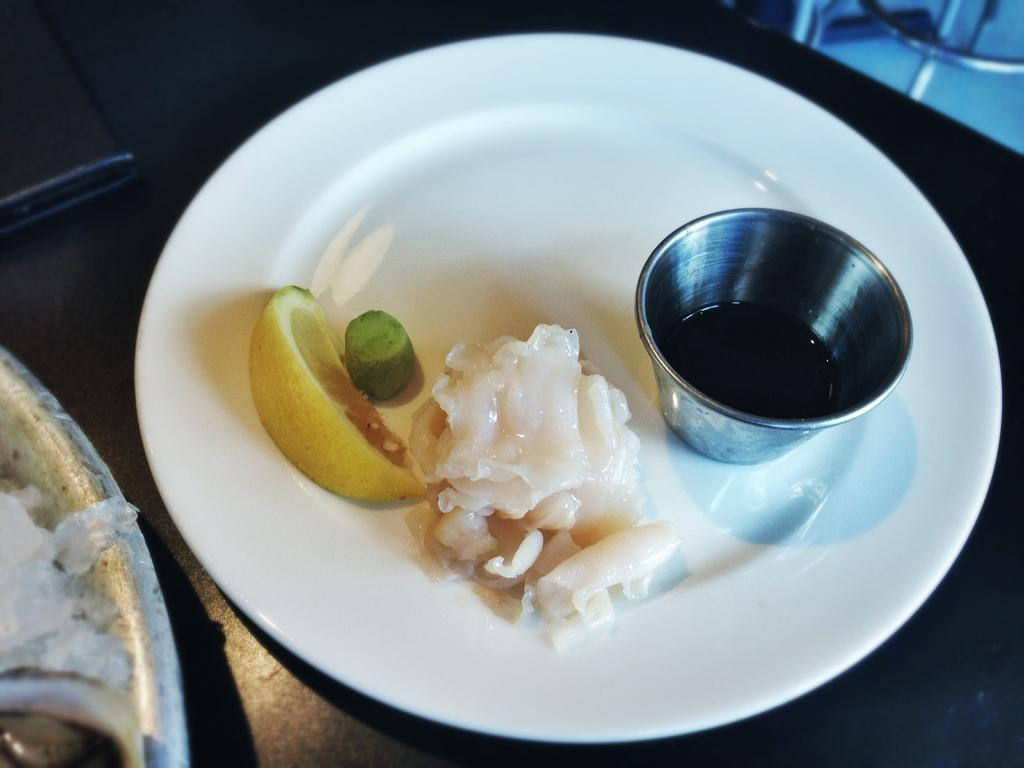What is in the bowl that is visible in the image? There is a bowl with liquid in the image. What else is present on the platform in the image? There is food in a plate in the image. Where are the bowl and plate located in the image? The bowl and plate are on a platform in the image. What can be seen on the left side of the image that appears to be partially cut off? There are objects on the left side of the image that are truncated. What is the price of the cactus in the image? There is no cactus present in the image, so it is not possible to determine its price. 